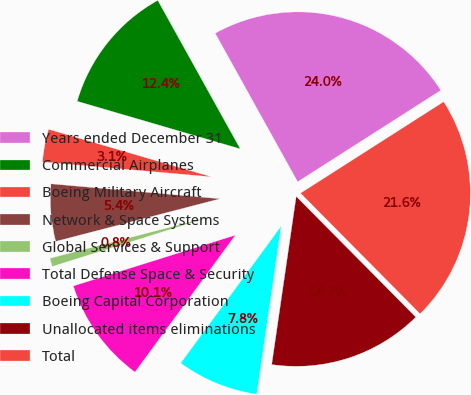Convert chart to OTSL. <chart><loc_0><loc_0><loc_500><loc_500><pie_chart><fcel>Years ended December 31<fcel>Commercial Airplanes<fcel>Boeing Military Aircraft<fcel>Network & Space Systems<fcel>Global Services & Support<fcel>Total Defense Space & Security<fcel>Boeing Capital Corporation<fcel>Unallocated items eliminations<fcel>Total<nl><fcel>24.02%<fcel>12.41%<fcel>3.12%<fcel>5.44%<fcel>0.8%<fcel>10.09%<fcel>7.77%<fcel>14.73%<fcel>21.62%<nl></chart> 